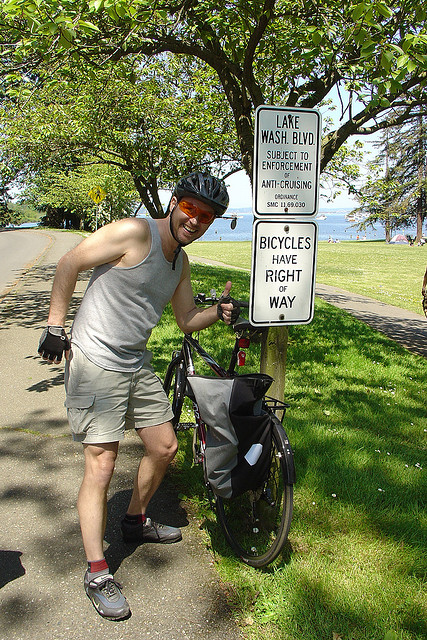Identify the text displayed in this image. LAKE WASH BLUD BICYCLES RIGHT WAY OF HAVE SUC CRUNSING ANTI ENFORCEMENT 10 SUBJECT 